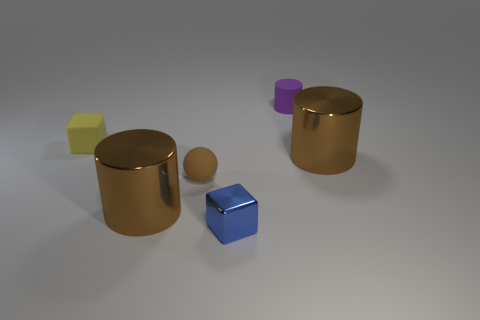There is another tiny thing that is the same shape as the yellow rubber object; what is it made of?
Your response must be concise. Metal. Are there more brown rubber balls than small blue matte blocks?
Keep it short and to the point. Yes. What number of other things are the same color as the small sphere?
Your answer should be very brief. 2. Is the small purple cylinder made of the same material as the large thing to the left of the tiny blue metallic block?
Provide a short and direct response. No. What number of matte objects are behind the metal thing behind the small matte thing in front of the small matte cube?
Your answer should be very brief. 2. Is the number of tiny yellow matte blocks on the left side of the yellow rubber cube less than the number of small brown rubber balls in front of the metal block?
Your answer should be compact. No. How many other things are there of the same material as the tiny yellow object?
Keep it short and to the point. 2. What is the material of the brown thing that is the same size as the yellow thing?
Your answer should be compact. Rubber. How many green things are either matte balls or metallic things?
Make the answer very short. 0. There is a rubber thing that is both on the right side of the small yellow thing and in front of the purple rubber thing; what is its color?
Make the answer very short. Brown. 